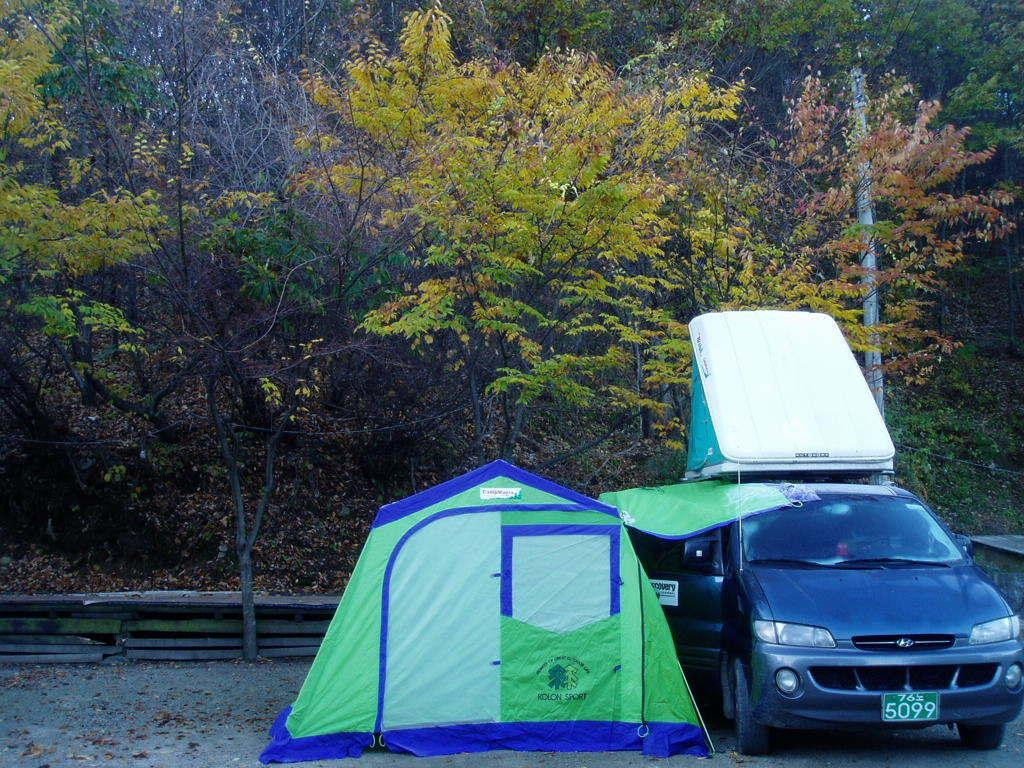What is the main subject in the image? There is a vehicle in the image. What else can be seen in the image besides the vehicle? There is a tent in the image. Where are the vehicle and tent located in the image? Both the vehicle and tent are on the road. What can be seen in the background of the image? There are trees, a pole, and a fence in the background of the image. What color is the trick in the image? There is no trick present in the image, and therefore no color can be assigned to it. 